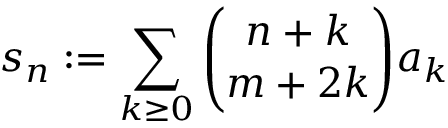Convert formula to latex. <formula><loc_0><loc_0><loc_500><loc_500>s _ { n } \colon = \sum _ { k \geq 0 } { \binom { n + k } { m + 2 k } } a _ { k }</formula> 